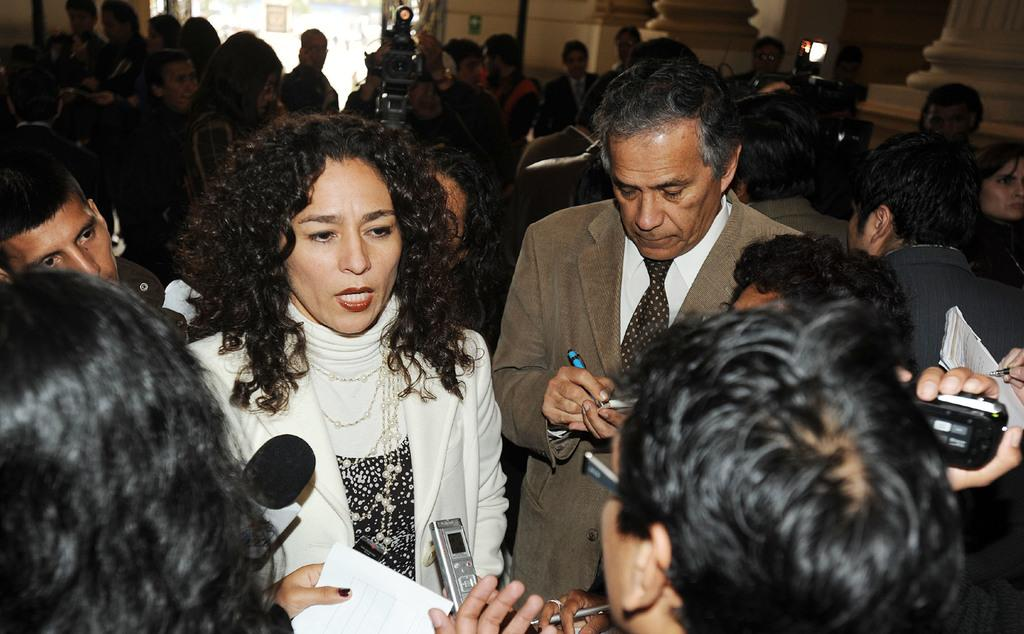How many people are present in the image? There are many people standing in the image. What are some of the objects that people are holding in the image? Some people are holding papers, mobile phones, pens, cameras, and books. What can be seen in the background of the image? There are pillars of a building in the background of the image. What type of bait is being used to catch fish in the image? There is no mention of fishing or bait in the image; it primarily features people holding various objects. What topic are the people discussing in the image? The image does not depict a discussion or conversation among the people; it simply shows them holding different objects. 